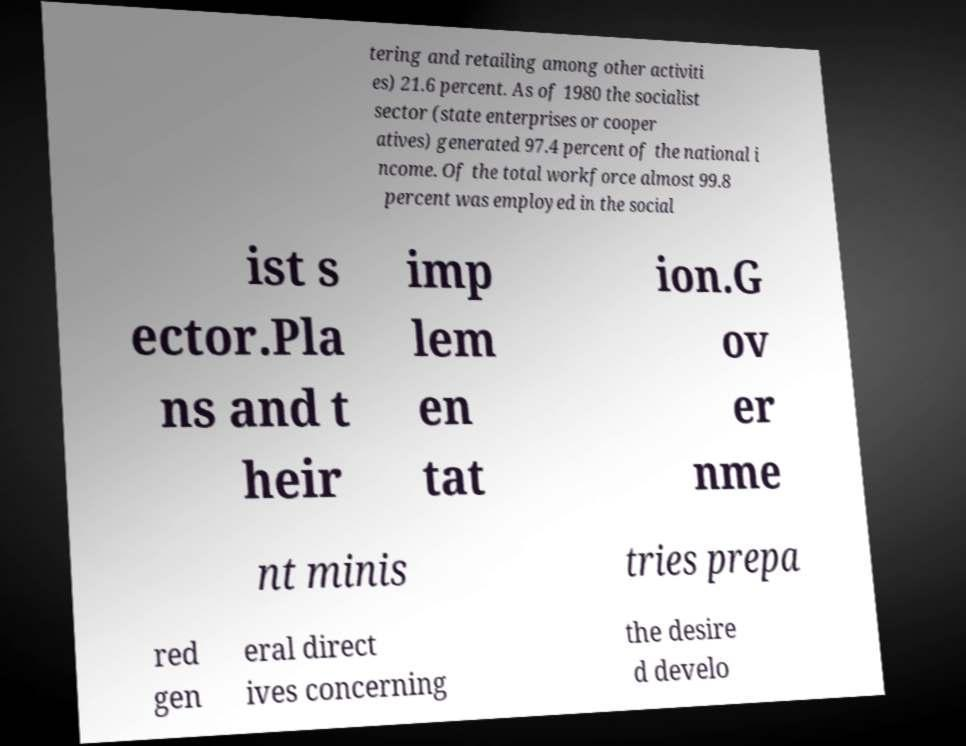There's text embedded in this image that I need extracted. Can you transcribe it verbatim? tering and retailing among other activiti es) 21.6 percent. As of 1980 the socialist sector (state enterprises or cooper atives) generated 97.4 percent of the national i ncome. Of the total workforce almost 99.8 percent was employed in the social ist s ector.Pla ns and t heir imp lem en tat ion.G ov er nme nt minis tries prepa red gen eral direct ives concerning the desire d develo 